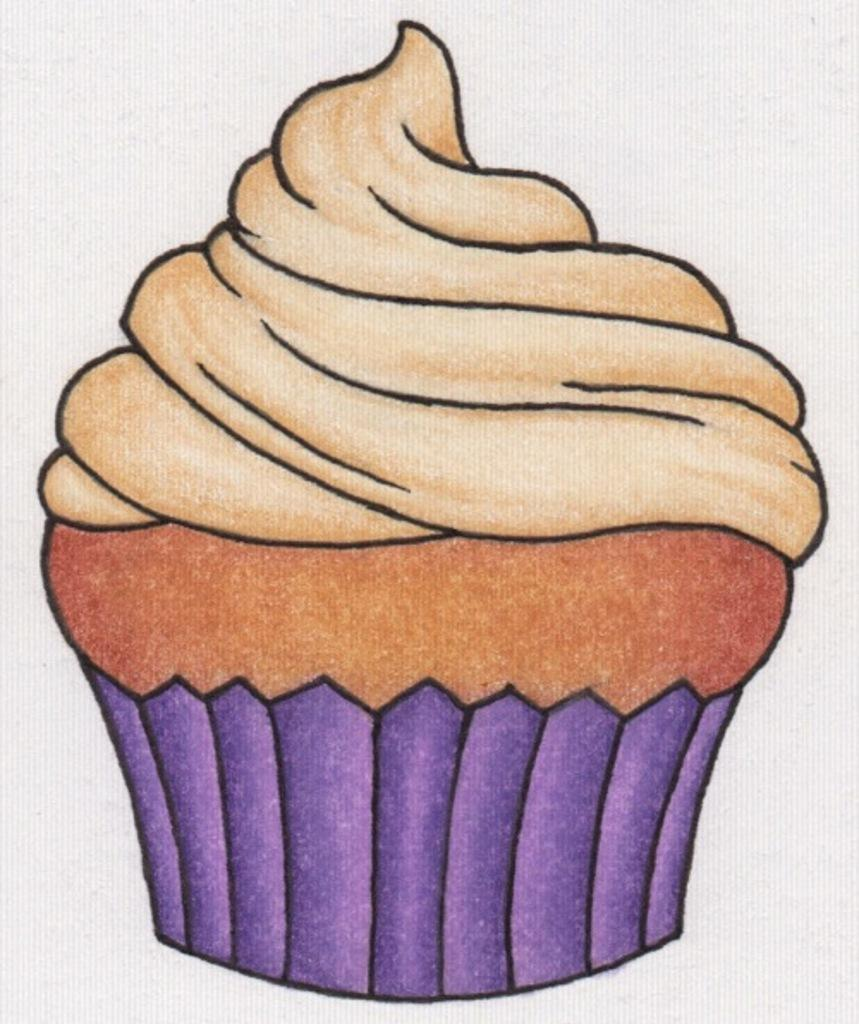What is depicted in the painting in the image? There is a painting of a cupcake in the image. What color is the background of the image? The background of the image is white. How many birthday profits are associated with the skirt in the image? There are no birthday profits or skirts mentioned in the image. 